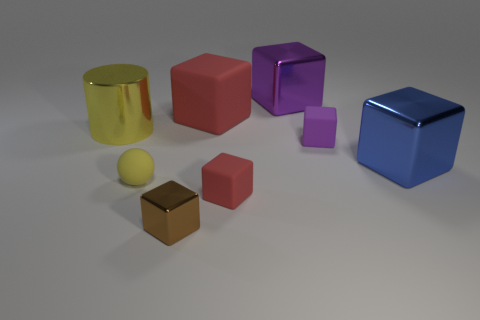What size is the rubber block on the left side of the red rubber block in front of the red matte cube that is behind the tiny purple block?
Provide a short and direct response. Large. Is the big yellow thing that is in front of the purple metal thing made of the same material as the tiny block that is on the left side of the tiny red matte object?
Give a very brief answer. Yes. How many other things are there of the same color as the big cylinder?
Give a very brief answer. 1. How many objects are either things that are right of the brown thing or tiny cubes that are to the right of the tiny brown thing?
Offer a terse response. 5. There is a metallic thing to the left of the metal cube to the left of the tiny red block; how big is it?
Keep it short and to the point. Large. What size is the yellow metal cylinder?
Provide a short and direct response. Large. There is a big metallic cube left of the small purple rubber cube; is its color the same as the matte cube right of the small red cube?
Your answer should be compact. Yes. What number of other things are the same material as the big yellow cylinder?
Your answer should be compact. 3. Are any shiny blocks visible?
Your answer should be compact. Yes. Do the thing that is in front of the small red rubber cube and the small purple cube have the same material?
Your response must be concise. No. 